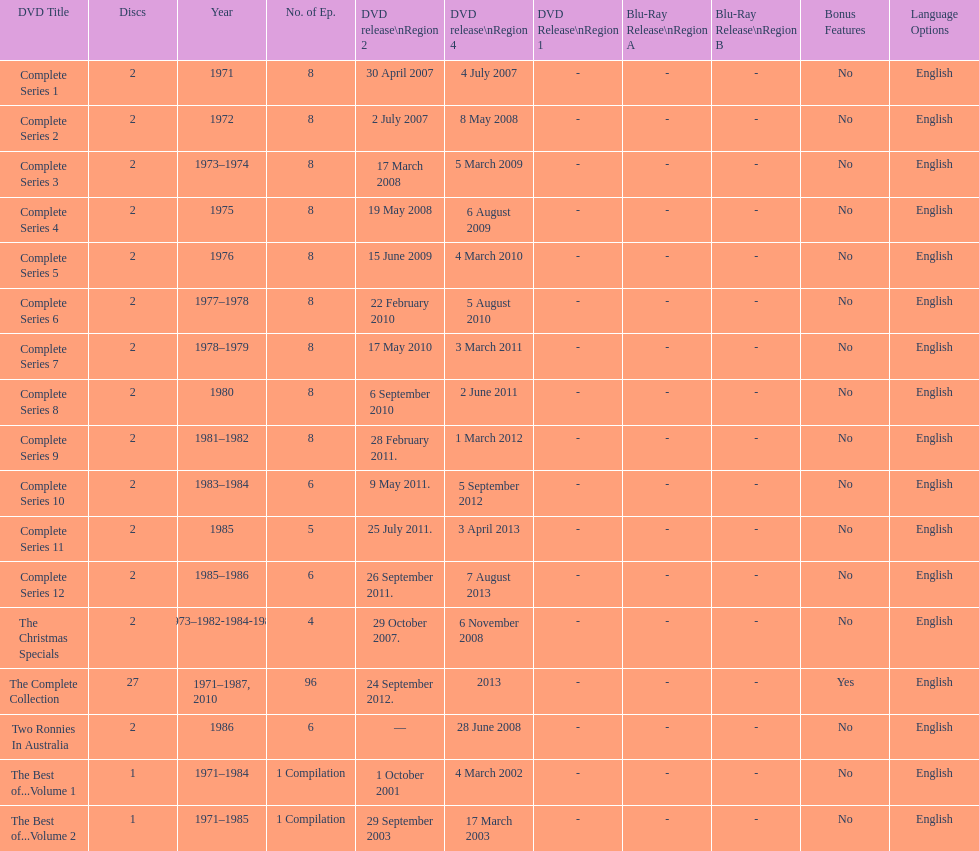Dvd shorter than 5 episodes The Christmas Specials. 